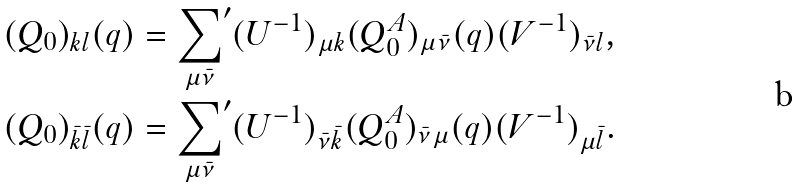<formula> <loc_0><loc_0><loc_500><loc_500>( Q _ { 0 } ) _ { k l } ( q ) & = { \sum _ { \mu \bar { \nu } } } ^ { \prime } ( U ^ { - 1 } ) _ { \mu k } ( Q ^ { A } _ { 0 } ) _ { \mu \bar { \nu } } ( q ) ( V ^ { - 1 } ) _ { \bar { \nu } l } , \\ ( Q _ { 0 } ) _ { \bar { k } \bar { l } } ( q ) & = { \sum _ { \mu \bar { \nu } } } ^ { \prime } ( U ^ { - 1 } ) _ { \bar { \nu } \bar { k } } ( Q ^ { A } _ { 0 } ) _ { \bar { \nu } \mu } ( q ) ( V ^ { - 1 } ) _ { \mu \bar { l } } .</formula> 